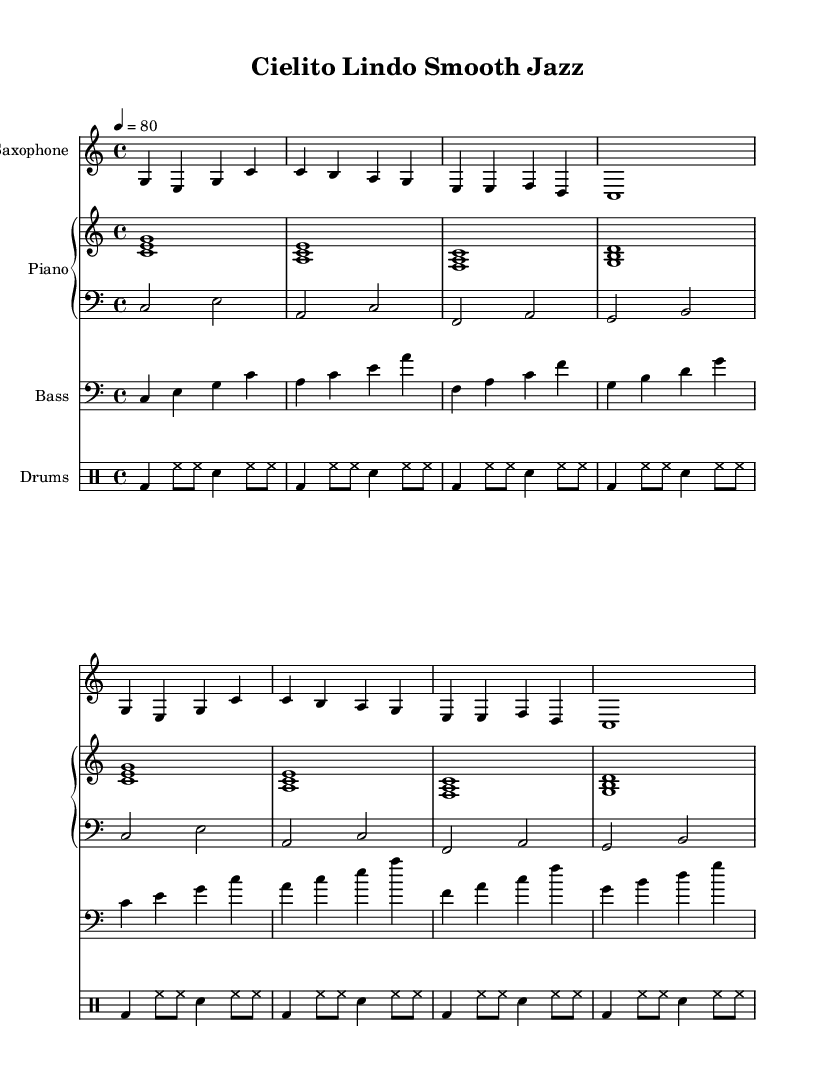What is the key signature of this music? The key signature is indicated at the beginning of the score. It shows C major, which has no sharps or flats.
Answer: C major What is the time signature of this music? The time signature is located after the key signature. It indicates that there are 4 beats in each measure, shown as 4/4.
Answer: 4/4 What is the tempo marking of this music? The tempo marking is placed at the beginning of the score and indicates the speed of the piece. It is set at quarter note = 80.
Answer: 80 How many measures are in the saxophone part? By counting the musical sections in the saxophone notes, we see there are 8 measures in total.
Answer: 8 What instruments are included in this smooth jazz arrangement? The score lists the instruments clearly at the beginning. The included instruments are Saxophone, Piano, Bass, and Drums.
Answer: Saxophone, Piano, Bass, Drums Which section features the left hand of the piano? The left hand part of the piano is specified under the clef 'bass' in the score, showing the lower notes being played with the left hand.
Answer: Clef: bass What is the rhythmic pattern of the drums? The rhythmic pattern for the drums is notated in the drum staff and comprises a repeating sequence of bass drum, hi-hat, and snare. It can be discerned through the notated drum symbols which follow a consistent pulse.
Answer: Bass, Hi-hat, Snare 